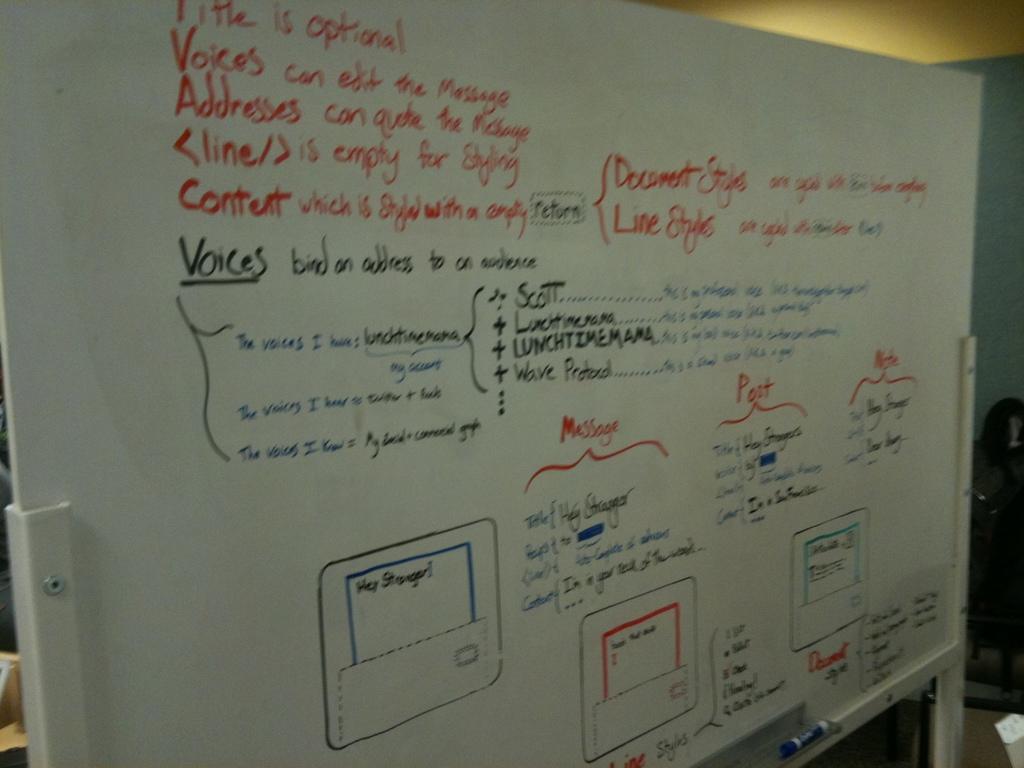What is the word underlined in blue on the left?
Offer a very short reply. Lunchtimemama. What is the writing  on?
Provide a short and direct response. White board. 